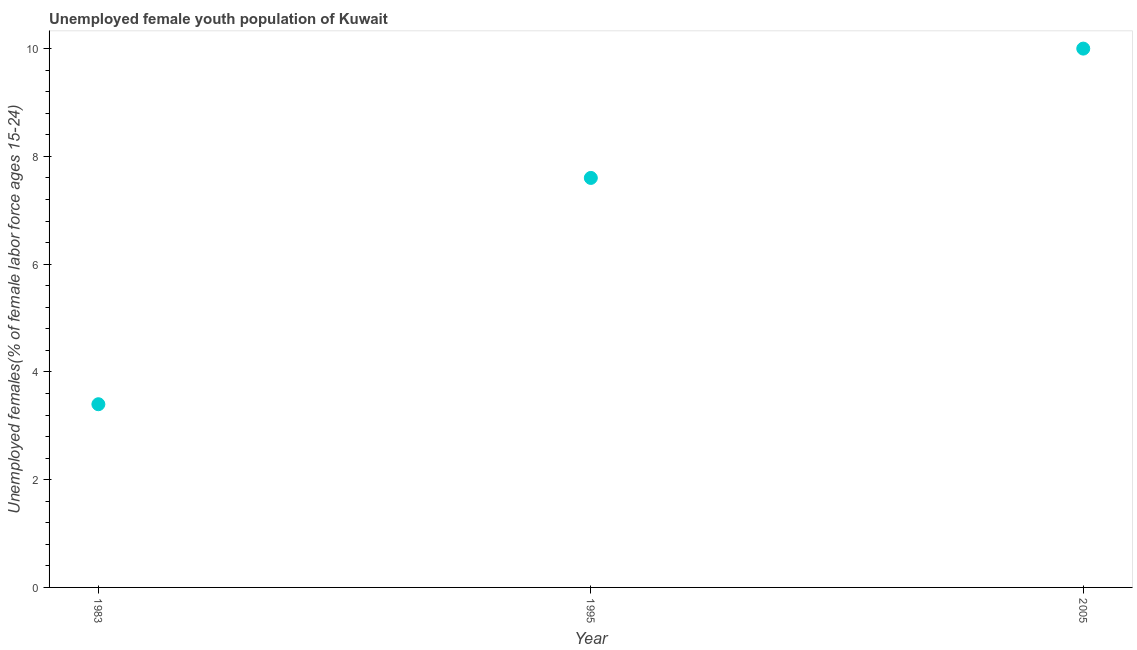What is the unemployed female youth in 1995?
Your response must be concise. 7.6. Across all years, what is the maximum unemployed female youth?
Keep it short and to the point. 10. Across all years, what is the minimum unemployed female youth?
Ensure brevity in your answer.  3.4. In which year was the unemployed female youth maximum?
Offer a very short reply. 2005. What is the difference between the unemployed female youth in 1983 and 1995?
Give a very brief answer. -4.2. What is the median unemployed female youth?
Your response must be concise. 7.6. What is the ratio of the unemployed female youth in 1995 to that in 2005?
Give a very brief answer. 0.76. What is the difference between the highest and the second highest unemployed female youth?
Your response must be concise. 2.4. Is the sum of the unemployed female youth in 1983 and 1995 greater than the maximum unemployed female youth across all years?
Give a very brief answer. Yes. What is the difference between the highest and the lowest unemployed female youth?
Your answer should be very brief. 6.6. Does the unemployed female youth monotonically increase over the years?
Provide a short and direct response. Yes. How many dotlines are there?
Make the answer very short. 1. Are the values on the major ticks of Y-axis written in scientific E-notation?
Offer a very short reply. No. Does the graph contain any zero values?
Provide a succinct answer. No. What is the title of the graph?
Ensure brevity in your answer.  Unemployed female youth population of Kuwait. What is the label or title of the Y-axis?
Your answer should be compact. Unemployed females(% of female labor force ages 15-24). What is the Unemployed females(% of female labor force ages 15-24) in 1983?
Your answer should be compact. 3.4. What is the Unemployed females(% of female labor force ages 15-24) in 1995?
Offer a very short reply. 7.6. What is the Unemployed females(% of female labor force ages 15-24) in 2005?
Provide a short and direct response. 10. What is the difference between the Unemployed females(% of female labor force ages 15-24) in 1983 and 1995?
Provide a succinct answer. -4.2. What is the difference between the Unemployed females(% of female labor force ages 15-24) in 1983 and 2005?
Keep it short and to the point. -6.6. What is the ratio of the Unemployed females(% of female labor force ages 15-24) in 1983 to that in 1995?
Offer a very short reply. 0.45. What is the ratio of the Unemployed females(% of female labor force ages 15-24) in 1983 to that in 2005?
Give a very brief answer. 0.34. What is the ratio of the Unemployed females(% of female labor force ages 15-24) in 1995 to that in 2005?
Offer a terse response. 0.76. 